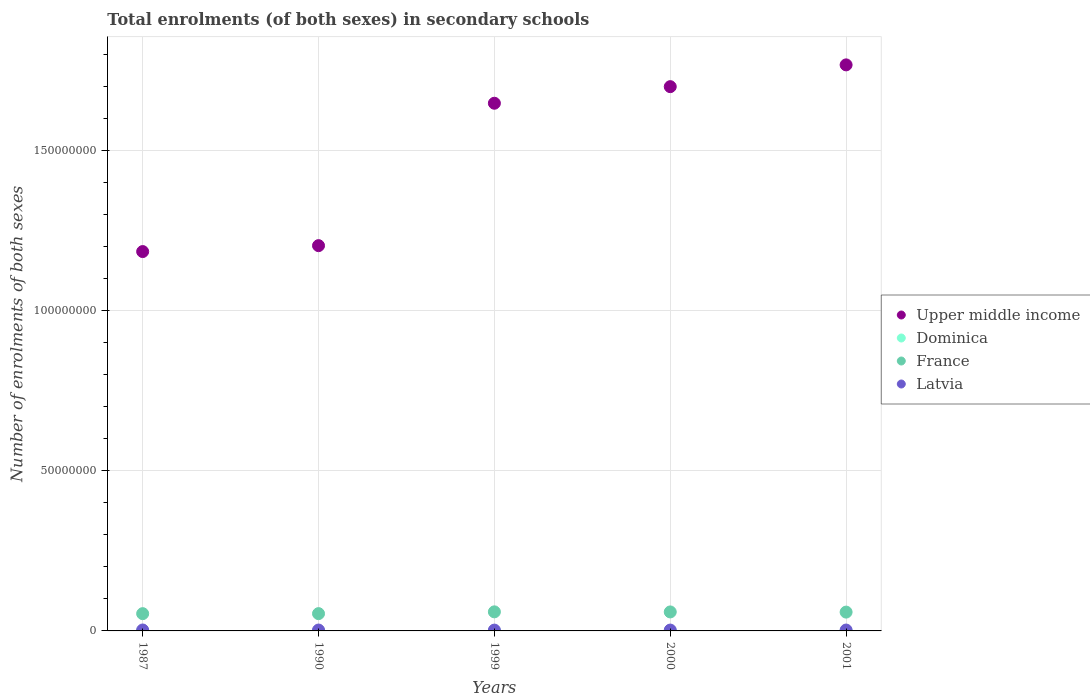What is the number of enrolments in secondary schools in Upper middle income in 1999?
Provide a succinct answer. 1.65e+08. Across all years, what is the maximum number of enrolments in secondary schools in France?
Offer a terse response. 5.96e+06. Across all years, what is the minimum number of enrolments in secondary schools in Latvia?
Provide a short and direct response. 2.55e+05. In which year was the number of enrolments in secondary schools in Dominica maximum?
Your answer should be very brief. 2001. What is the total number of enrolments in secondary schools in Latvia in the graph?
Offer a very short reply. 1.36e+06. What is the difference between the number of enrolments in secondary schools in Latvia in 1999 and that in 2000?
Your response must be concise. -1.11e+04. What is the difference between the number of enrolments in secondary schools in Upper middle income in 1999 and the number of enrolments in secondary schools in Dominica in 1990?
Make the answer very short. 1.65e+08. What is the average number of enrolments in secondary schools in Dominica per year?
Make the answer very short. 6790.6. In the year 2000, what is the difference between the number of enrolments in secondary schools in France and number of enrolments in secondary schools in Latvia?
Offer a terse response. 5.66e+06. In how many years, is the number of enrolments in secondary schools in Upper middle income greater than 170000000?
Provide a short and direct response. 1. What is the ratio of the number of enrolments in secondary schools in Latvia in 2000 to that in 2001?
Your response must be concise. 0.97. Is the difference between the number of enrolments in secondary schools in France in 1987 and 1999 greater than the difference between the number of enrolments in secondary schools in Latvia in 1987 and 1999?
Ensure brevity in your answer.  No. What is the difference between the highest and the second highest number of enrolments in secondary schools in Latvia?
Offer a terse response. 1.36e+04. What is the difference between the highest and the lowest number of enrolments in secondary schools in Latvia?
Your answer should be compact. 3.34e+04. Is it the case that in every year, the sum of the number of enrolments in secondary schools in Dominica and number of enrolments in secondary schools in Upper middle income  is greater than the sum of number of enrolments in secondary schools in France and number of enrolments in secondary schools in Latvia?
Keep it short and to the point. Yes. Is it the case that in every year, the sum of the number of enrolments in secondary schools in France and number of enrolments in secondary schools in Upper middle income  is greater than the number of enrolments in secondary schools in Dominica?
Your answer should be very brief. Yes. Is the number of enrolments in secondary schools in Upper middle income strictly less than the number of enrolments in secondary schools in Dominica over the years?
Offer a terse response. No. How many years are there in the graph?
Your answer should be very brief. 5. Does the graph contain grids?
Offer a very short reply. Yes. Where does the legend appear in the graph?
Offer a terse response. Center right. What is the title of the graph?
Your response must be concise. Total enrolments (of both sexes) in secondary schools. What is the label or title of the X-axis?
Offer a very short reply. Years. What is the label or title of the Y-axis?
Give a very brief answer. Number of enrolments of both sexes. What is the Number of enrolments of both sexes of Upper middle income in 1987?
Keep it short and to the point. 1.18e+08. What is the Number of enrolments of both sexes in Dominica in 1987?
Your response must be concise. 6308. What is the Number of enrolments of both sexes in France in 1987?
Make the answer very short. 5.39e+06. What is the Number of enrolments of both sexes in Latvia in 1987?
Make the answer very short. 2.89e+05. What is the Number of enrolments of both sexes in Upper middle income in 1990?
Provide a succinct answer. 1.20e+08. What is the Number of enrolments of both sexes in Dominica in 1990?
Keep it short and to the point. 5634. What is the Number of enrolments of both sexes of France in 1990?
Your answer should be compact. 5.40e+06. What is the Number of enrolments of both sexes in Latvia in 1990?
Offer a very short reply. 2.75e+05. What is the Number of enrolments of both sexes of Upper middle income in 1999?
Offer a terse response. 1.65e+08. What is the Number of enrolments of both sexes in Dominica in 1999?
Offer a very short reply. 7126. What is the Number of enrolments of both sexes of France in 1999?
Your response must be concise. 5.96e+06. What is the Number of enrolments of both sexes of Latvia in 1999?
Your answer should be very brief. 2.55e+05. What is the Number of enrolments of both sexes in Upper middle income in 2000?
Your answer should be very brief. 1.70e+08. What is the Number of enrolments of both sexes in Dominica in 2000?
Offer a very short reply. 7429. What is the Number of enrolments of both sexes of France in 2000?
Make the answer very short. 5.93e+06. What is the Number of enrolments of both sexes in Latvia in 2000?
Provide a short and direct response. 2.66e+05. What is the Number of enrolments of both sexes in Upper middle income in 2001?
Provide a short and direct response. 1.77e+08. What is the Number of enrolments of both sexes in Dominica in 2001?
Ensure brevity in your answer.  7456. What is the Number of enrolments of both sexes of France in 2001?
Keep it short and to the point. 5.88e+06. What is the Number of enrolments of both sexes in Latvia in 2001?
Give a very brief answer. 2.74e+05. Across all years, what is the maximum Number of enrolments of both sexes in Upper middle income?
Provide a short and direct response. 1.77e+08. Across all years, what is the maximum Number of enrolments of both sexes in Dominica?
Give a very brief answer. 7456. Across all years, what is the maximum Number of enrolments of both sexes in France?
Make the answer very short. 5.96e+06. Across all years, what is the maximum Number of enrolments of both sexes in Latvia?
Offer a terse response. 2.89e+05. Across all years, what is the minimum Number of enrolments of both sexes of Upper middle income?
Provide a succinct answer. 1.18e+08. Across all years, what is the minimum Number of enrolments of both sexes of Dominica?
Provide a succinct answer. 5634. Across all years, what is the minimum Number of enrolments of both sexes in France?
Make the answer very short. 5.39e+06. Across all years, what is the minimum Number of enrolments of both sexes of Latvia?
Your response must be concise. 2.55e+05. What is the total Number of enrolments of both sexes of Upper middle income in the graph?
Provide a succinct answer. 7.50e+08. What is the total Number of enrolments of both sexes of Dominica in the graph?
Ensure brevity in your answer.  3.40e+04. What is the total Number of enrolments of both sexes in France in the graph?
Offer a terse response. 2.85e+07. What is the total Number of enrolments of both sexes of Latvia in the graph?
Your answer should be very brief. 1.36e+06. What is the difference between the Number of enrolments of both sexes in Upper middle income in 1987 and that in 1990?
Your response must be concise. -1.85e+06. What is the difference between the Number of enrolments of both sexes in Dominica in 1987 and that in 1990?
Your response must be concise. 674. What is the difference between the Number of enrolments of both sexes of France in 1987 and that in 1990?
Provide a short and direct response. -8793. What is the difference between the Number of enrolments of both sexes in Latvia in 1987 and that in 1990?
Offer a very short reply. 1.36e+04. What is the difference between the Number of enrolments of both sexes of Upper middle income in 1987 and that in 1999?
Ensure brevity in your answer.  -4.63e+07. What is the difference between the Number of enrolments of both sexes of Dominica in 1987 and that in 1999?
Your answer should be compact. -818. What is the difference between the Number of enrolments of both sexes of France in 1987 and that in 1999?
Provide a succinct answer. -5.66e+05. What is the difference between the Number of enrolments of both sexes of Latvia in 1987 and that in 1999?
Your response must be concise. 3.34e+04. What is the difference between the Number of enrolments of both sexes of Upper middle income in 1987 and that in 2000?
Your response must be concise. -5.15e+07. What is the difference between the Number of enrolments of both sexes of Dominica in 1987 and that in 2000?
Ensure brevity in your answer.  -1121. What is the difference between the Number of enrolments of both sexes in France in 1987 and that in 2000?
Provide a succinct answer. -5.39e+05. What is the difference between the Number of enrolments of both sexes of Latvia in 1987 and that in 2000?
Offer a very short reply. 2.23e+04. What is the difference between the Number of enrolments of both sexes of Upper middle income in 1987 and that in 2001?
Provide a succinct answer. -5.83e+07. What is the difference between the Number of enrolments of both sexes in Dominica in 1987 and that in 2001?
Offer a very short reply. -1148. What is the difference between the Number of enrolments of both sexes in France in 1987 and that in 2001?
Your answer should be compact. -4.86e+05. What is the difference between the Number of enrolments of both sexes in Latvia in 1987 and that in 2001?
Give a very brief answer. 1.46e+04. What is the difference between the Number of enrolments of both sexes in Upper middle income in 1990 and that in 1999?
Your answer should be compact. -4.45e+07. What is the difference between the Number of enrolments of both sexes in Dominica in 1990 and that in 1999?
Offer a very short reply. -1492. What is the difference between the Number of enrolments of both sexes of France in 1990 and that in 1999?
Offer a very short reply. -5.57e+05. What is the difference between the Number of enrolments of both sexes of Latvia in 1990 and that in 1999?
Your response must be concise. 1.97e+04. What is the difference between the Number of enrolments of both sexes of Upper middle income in 1990 and that in 2000?
Ensure brevity in your answer.  -4.96e+07. What is the difference between the Number of enrolments of both sexes of Dominica in 1990 and that in 2000?
Give a very brief answer. -1795. What is the difference between the Number of enrolments of both sexes of France in 1990 and that in 2000?
Provide a succinct answer. -5.30e+05. What is the difference between the Number of enrolments of both sexes in Latvia in 1990 and that in 2000?
Offer a very short reply. 8624. What is the difference between the Number of enrolments of both sexes of Upper middle income in 1990 and that in 2001?
Offer a terse response. -5.64e+07. What is the difference between the Number of enrolments of both sexes of Dominica in 1990 and that in 2001?
Provide a short and direct response. -1822. What is the difference between the Number of enrolments of both sexes of France in 1990 and that in 2001?
Offer a very short reply. -4.77e+05. What is the difference between the Number of enrolments of both sexes of Latvia in 1990 and that in 2001?
Provide a succinct answer. 929. What is the difference between the Number of enrolments of both sexes of Upper middle income in 1999 and that in 2000?
Your answer should be very brief. -5.18e+06. What is the difference between the Number of enrolments of both sexes of Dominica in 1999 and that in 2000?
Your response must be concise. -303. What is the difference between the Number of enrolments of both sexes in France in 1999 and that in 2000?
Make the answer very short. 2.68e+04. What is the difference between the Number of enrolments of both sexes of Latvia in 1999 and that in 2000?
Your answer should be very brief. -1.11e+04. What is the difference between the Number of enrolments of both sexes in Upper middle income in 1999 and that in 2001?
Make the answer very short. -1.20e+07. What is the difference between the Number of enrolments of both sexes in Dominica in 1999 and that in 2001?
Give a very brief answer. -330. What is the difference between the Number of enrolments of both sexes in France in 1999 and that in 2001?
Keep it short and to the point. 7.94e+04. What is the difference between the Number of enrolments of both sexes of Latvia in 1999 and that in 2001?
Your response must be concise. -1.88e+04. What is the difference between the Number of enrolments of both sexes in Upper middle income in 2000 and that in 2001?
Your answer should be compact. -6.80e+06. What is the difference between the Number of enrolments of both sexes in France in 2000 and that in 2001?
Offer a very short reply. 5.27e+04. What is the difference between the Number of enrolments of both sexes of Latvia in 2000 and that in 2001?
Keep it short and to the point. -7695. What is the difference between the Number of enrolments of both sexes of Upper middle income in 1987 and the Number of enrolments of both sexes of Dominica in 1990?
Offer a terse response. 1.18e+08. What is the difference between the Number of enrolments of both sexes of Upper middle income in 1987 and the Number of enrolments of both sexes of France in 1990?
Make the answer very short. 1.13e+08. What is the difference between the Number of enrolments of both sexes in Upper middle income in 1987 and the Number of enrolments of both sexes in Latvia in 1990?
Give a very brief answer. 1.18e+08. What is the difference between the Number of enrolments of both sexes in Dominica in 1987 and the Number of enrolments of both sexes in France in 1990?
Offer a terse response. -5.39e+06. What is the difference between the Number of enrolments of both sexes in Dominica in 1987 and the Number of enrolments of both sexes in Latvia in 1990?
Offer a terse response. -2.69e+05. What is the difference between the Number of enrolments of both sexes of France in 1987 and the Number of enrolments of both sexes of Latvia in 1990?
Your response must be concise. 5.11e+06. What is the difference between the Number of enrolments of both sexes of Upper middle income in 1987 and the Number of enrolments of both sexes of Dominica in 1999?
Your response must be concise. 1.18e+08. What is the difference between the Number of enrolments of both sexes of Upper middle income in 1987 and the Number of enrolments of both sexes of France in 1999?
Your response must be concise. 1.12e+08. What is the difference between the Number of enrolments of both sexes in Upper middle income in 1987 and the Number of enrolments of both sexes in Latvia in 1999?
Make the answer very short. 1.18e+08. What is the difference between the Number of enrolments of both sexes of Dominica in 1987 and the Number of enrolments of both sexes of France in 1999?
Offer a very short reply. -5.95e+06. What is the difference between the Number of enrolments of both sexes of Dominica in 1987 and the Number of enrolments of both sexes of Latvia in 1999?
Your answer should be very brief. -2.49e+05. What is the difference between the Number of enrolments of both sexes of France in 1987 and the Number of enrolments of both sexes of Latvia in 1999?
Offer a terse response. 5.13e+06. What is the difference between the Number of enrolments of both sexes in Upper middle income in 1987 and the Number of enrolments of both sexes in Dominica in 2000?
Your response must be concise. 1.18e+08. What is the difference between the Number of enrolments of both sexes of Upper middle income in 1987 and the Number of enrolments of both sexes of France in 2000?
Provide a short and direct response. 1.13e+08. What is the difference between the Number of enrolments of both sexes of Upper middle income in 1987 and the Number of enrolments of both sexes of Latvia in 2000?
Ensure brevity in your answer.  1.18e+08. What is the difference between the Number of enrolments of both sexes of Dominica in 1987 and the Number of enrolments of both sexes of France in 2000?
Your answer should be compact. -5.92e+06. What is the difference between the Number of enrolments of both sexes of Dominica in 1987 and the Number of enrolments of both sexes of Latvia in 2000?
Offer a terse response. -2.60e+05. What is the difference between the Number of enrolments of both sexes in France in 1987 and the Number of enrolments of both sexes in Latvia in 2000?
Provide a short and direct response. 5.12e+06. What is the difference between the Number of enrolments of both sexes of Upper middle income in 1987 and the Number of enrolments of both sexes of Dominica in 2001?
Provide a short and direct response. 1.18e+08. What is the difference between the Number of enrolments of both sexes of Upper middle income in 1987 and the Number of enrolments of both sexes of France in 2001?
Your answer should be compact. 1.13e+08. What is the difference between the Number of enrolments of both sexes of Upper middle income in 1987 and the Number of enrolments of both sexes of Latvia in 2001?
Your response must be concise. 1.18e+08. What is the difference between the Number of enrolments of both sexes in Dominica in 1987 and the Number of enrolments of both sexes in France in 2001?
Offer a very short reply. -5.87e+06. What is the difference between the Number of enrolments of both sexes of Dominica in 1987 and the Number of enrolments of both sexes of Latvia in 2001?
Your response must be concise. -2.68e+05. What is the difference between the Number of enrolments of both sexes in France in 1987 and the Number of enrolments of both sexes in Latvia in 2001?
Make the answer very short. 5.12e+06. What is the difference between the Number of enrolments of both sexes in Upper middle income in 1990 and the Number of enrolments of both sexes in Dominica in 1999?
Give a very brief answer. 1.20e+08. What is the difference between the Number of enrolments of both sexes in Upper middle income in 1990 and the Number of enrolments of both sexes in France in 1999?
Offer a terse response. 1.14e+08. What is the difference between the Number of enrolments of both sexes of Upper middle income in 1990 and the Number of enrolments of both sexes of Latvia in 1999?
Offer a terse response. 1.20e+08. What is the difference between the Number of enrolments of both sexes in Dominica in 1990 and the Number of enrolments of both sexes in France in 1999?
Make the answer very short. -5.95e+06. What is the difference between the Number of enrolments of both sexes in Dominica in 1990 and the Number of enrolments of both sexes in Latvia in 1999?
Provide a succinct answer. -2.50e+05. What is the difference between the Number of enrolments of both sexes in France in 1990 and the Number of enrolments of both sexes in Latvia in 1999?
Provide a short and direct response. 5.14e+06. What is the difference between the Number of enrolments of both sexes in Upper middle income in 1990 and the Number of enrolments of both sexes in Dominica in 2000?
Your response must be concise. 1.20e+08. What is the difference between the Number of enrolments of both sexes in Upper middle income in 1990 and the Number of enrolments of both sexes in France in 2000?
Keep it short and to the point. 1.14e+08. What is the difference between the Number of enrolments of both sexes of Upper middle income in 1990 and the Number of enrolments of both sexes of Latvia in 2000?
Make the answer very short. 1.20e+08. What is the difference between the Number of enrolments of both sexes in Dominica in 1990 and the Number of enrolments of both sexes in France in 2000?
Keep it short and to the point. -5.92e+06. What is the difference between the Number of enrolments of both sexes in Dominica in 1990 and the Number of enrolments of both sexes in Latvia in 2000?
Provide a short and direct response. -2.61e+05. What is the difference between the Number of enrolments of both sexes in France in 1990 and the Number of enrolments of both sexes in Latvia in 2000?
Give a very brief answer. 5.13e+06. What is the difference between the Number of enrolments of both sexes of Upper middle income in 1990 and the Number of enrolments of both sexes of Dominica in 2001?
Keep it short and to the point. 1.20e+08. What is the difference between the Number of enrolments of both sexes in Upper middle income in 1990 and the Number of enrolments of both sexes in France in 2001?
Offer a terse response. 1.14e+08. What is the difference between the Number of enrolments of both sexes in Upper middle income in 1990 and the Number of enrolments of both sexes in Latvia in 2001?
Provide a short and direct response. 1.20e+08. What is the difference between the Number of enrolments of both sexes in Dominica in 1990 and the Number of enrolments of both sexes in France in 2001?
Provide a short and direct response. -5.87e+06. What is the difference between the Number of enrolments of both sexes of Dominica in 1990 and the Number of enrolments of both sexes of Latvia in 2001?
Ensure brevity in your answer.  -2.69e+05. What is the difference between the Number of enrolments of both sexes of France in 1990 and the Number of enrolments of both sexes of Latvia in 2001?
Offer a terse response. 5.12e+06. What is the difference between the Number of enrolments of both sexes of Upper middle income in 1999 and the Number of enrolments of both sexes of Dominica in 2000?
Your response must be concise. 1.65e+08. What is the difference between the Number of enrolments of both sexes of Upper middle income in 1999 and the Number of enrolments of both sexes of France in 2000?
Ensure brevity in your answer.  1.59e+08. What is the difference between the Number of enrolments of both sexes of Upper middle income in 1999 and the Number of enrolments of both sexes of Latvia in 2000?
Your answer should be compact. 1.64e+08. What is the difference between the Number of enrolments of both sexes in Dominica in 1999 and the Number of enrolments of both sexes in France in 2000?
Give a very brief answer. -5.92e+06. What is the difference between the Number of enrolments of both sexes of Dominica in 1999 and the Number of enrolments of both sexes of Latvia in 2000?
Offer a terse response. -2.59e+05. What is the difference between the Number of enrolments of both sexes in France in 1999 and the Number of enrolments of both sexes in Latvia in 2000?
Provide a succinct answer. 5.69e+06. What is the difference between the Number of enrolments of both sexes of Upper middle income in 1999 and the Number of enrolments of both sexes of Dominica in 2001?
Offer a very short reply. 1.65e+08. What is the difference between the Number of enrolments of both sexes of Upper middle income in 1999 and the Number of enrolments of both sexes of France in 2001?
Give a very brief answer. 1.59e+08. What is the difference between the Number of enrolments of both sexes of Upper middle income in 1999 and the Number of enrolments of both sexes of Latvia in 2001?
Give a very brief answer. 1.64e+08. What is the difference between the Number of enrolments of both sexes in Dominica in 1999 and the Number of enrolments of both sexes in France in 2001?
Offer a terse response. -5.87e+06. What is the difference between the Number of enrolments of both sexes in Dominica in 1999 and the Number of enrolments of both sexes in Latvia in 2001?
Your answer should be very brief. -2.67e+05. What is the difference between the Number of enrolments of both sexes in France in 1999 and the Number of enrolments of both sexes in Latvia in 2001?
Keep it short and to the point. 5.68e+06. What is the difference between the Number of enrolments of both sexes of Upper middle income in 2000 and the Number of enrolments of both sexes of Dominica in 2001?
Provide a succinct answer. 1.70e+08. What is the difference between the Number of enrolments of both sexes of Upper middle income in 2000 and the Number of enrolments of both sexes of France in 2001?
Make the answer very short. 1.64e+08. What is the difference between the Number of enrolments of both sexes in Upper middle income in 2000 and the Number of enrolments of both sexes in Latvia in 2001?
Ensure brevity in your answer.  1.70e+08. What is the difference between the Number of enrolments of both sexes in Dominica in 2000 and the Number of enrolments of both sexes in France in 2001?
Offer a terse response. -5.87e+06. What is the difference between the Number of enrolments of both sexes of Dominica in 2000 and the Number of enrolments of both sexes of Latvia in 2001?
Your answer should be compact. -2.67e+05. What is the difference between the Number of enrolments of both sexes of France in 2000 and the Number of enrolments of both sexes of Latvia in 2001?
Make the answer very short. 5.65e+06. What is the average Number of enrolments of both sexes in Upper middle income per year?
Your response must be concise. 1.50e+08. What is the average Number of enrolments of both sexes in Dominica per year?
Your answer should be compact. 6790.6. What is the average Number of enrolments of both sexes of France per year?
Make the answer very short. 5.71e+06. What is the average Number of enrolments of both sexes in Latvia per year?
Your answer should be very brief. 2.72e+05. In the year 1987, what is the difference between the Number of enrolments of both sexes in Upper middle income and Number of enrolments of both sexes in Dominica?
Your answer should be very brief. 1.18e+08. In the year 1987, what is the difference between the Number of enrolments of both sexes in Upper middle income and Number of enrolments of both sexes in France?
Ensure brevity in your answer.  1.13e+08. In the year 1987, what is the difference between the Number of enrolments of both sexes of Upper middle income and Number of enrolments of both sexes of Latvia?
Provide a short and direct response. 1.18e+08. In the year 1987, what is the difference between the Number of enrolments of both sexes in Dominica and Number of enrolments of both sexes in France?
Your answer should be very brief. -5.38e+06. In the year 1987, what is the difference between the Number of enrolments of both sexes in Dominica and Number of enrolments of both sexes in Latvia?
Your response must be concise. -2.82e+05. In the year 1987, what is the difference between the Number of enrolments of both sexes of France and Number of enrolments of both sexes of Latvia?
Your response must be concise. 5.10e+06. In the year 1990, what is the difference between the Number of enrolments of both sexes in Upper middle income and Number of enrolments of both sexes in Dominica?
Your answer should be very brief. 1.20e+08. In the year 1990, what is the difference between the Number of enrolments of both sexes in Upper middle income and Number of enrolments of both sexes in France?
Your response must be concise. 1.15e+08. In the year 1990, what is the difference between the Number of enrolments of both sexes in Upper middle income and Number of enrolments of both sexes in Latvia?
Ensure brevity in your answer.  1.20e+08. In the year 1990, what is the difference between the Number of enrolments of both sexes of Dominica and Number of enrolments of both sexes of France?
Provide a short and direct response. -5.39e+06. In the year 1990, what is the difference between the Number of enrolments of both sexes of Dominica and Number of enrolments of both sexes of Latvia?
Offer a terse response. -2.69e+05. In the year 1990, what is the difference between the Number of enrolments of both sexes in France and Number of enrolments of both sexes in Latvia?
Offer a terse response. 5.12e+06. In the year 1999, what is the difference between the Number of enrolments of both sexes in Upper middle income and Number of enrolments of both sexes in Dominica?
Give a very brief answer. 1.65e+08. In the year 1999, what is the difference between the Number of enrolments of both sexes of Upper middle income and Number of enrolments of both sexes of France?
Provide a succinct answer. 1.59e+08. In the year 1999, what is the difference between the Number of enrolments of both sexes of Upper middle income and Number of enrolments of both sexes of Latvia?
Your answer should be very brief. 1.64e+08. In the year 1999, what is the difference between the Number of enrolments of both sexes of Dominica and Number of enrolments of both sexes of France?
Give a very brief answer. -5.95e+06. In the year 1999, what is the difference between the Number of enrolments of both sexes of Dominica and Number of enrolments of both sexes of Latvia?
Provide a succinct answer. -2.48e+05. In the year 1999, what is the difference between the Number of enrolments of both sexes in France and Number of enrolments of both sexes in Latvia?
Keep it short and to the point. 5.70e+06. In the year 2000, what is the difference between the Number of enrolments of both sexes of Upper middle income and Number of enrolments of both sexes of Dominica?
Keep it short and to the point. 1.70e+08. In the year 2000, what is the difference between the Number of enrolments of both sexes in Upper middle income and Number of enrolments of both sexes in France?
Provide a succinct answer. 1.64e+08. In the year 2000, what is the difference between the Number of enrolments of both sexes of Upper middle income and Number of enrolments of both sexes of Latvia?
Your response must be concise. 1.70e+08. In the year 2000, what is the difference between the Number of enrolments of both sexes of Dominica and Number of enrolments of both sexes of France?
Make the answer very short. -5.92e+06. In the year 2000, what is the difference between the Number of enrolments of both sexes of Dominica and Number of enrolments of both sexes of Latvia?
Offer a terse response. -2.59e+05. In the year 2000, what is the difference between the Number of enrolments of both sexes of France and Number of enrolments of both sexes of Latvia?
Give a very brief answer. 5.66e+06. In the year 2001, what is the difference between the Number of enrolments of both sexes of Upper middle income and Number of enrolments of both sexes of Dominica?
Give a very brief answer. 1.77e+08. In the year 2001, what is the difference between the Number of enrolments of both sexes of Upper middle income and Number of enrolments of both sexes of France?
Offer a terse response. 1.71e+08. In the year 2001, what is the difference between the Number of enrolments of both sexes in Upper middle income and Number of enrolments of both sexes in Latvia?
Ensure brevity in your answer.  1.76e+08. In the year 2001, what is the difference between the Number of enrolments of both sexes in Dominica and Number of enrolments of both sexes in France?
Give a very brief answer. -5.87e+06. In the year 2001, what is the difference between the Number of enrolments of both sexes of Dominica and Number of enrolments of both sexes of Latvia?
Keep it short and to the point. -2.67e+05. In the year 2001, what is the difference between the Number of enrolments of both sexes in France and Number of enrolments of both sexes in Latvia?
Ensure brevity in your answer.  5.60e+06. What is the ratio of the Number of enrolments of both sexes in Upper middle income in 1987 to that in 1990?
Your response must be concise. 0.98. What is the ratio of the Number of enrolments of both sexes of Dominica in 1987 to that in 1990?
Your response must be concise. 1.12. What is the ratio of the Number of enrolments of both sexes of Latvia in 1987 to that in 1990?
Provide a succinct answer. 1.05. What is the ratio of the Number of enrolments of both sexes of Upper middle income in 1987 to that in 1999?
Keep it short and to the point. 0.72. What is the ratio of the Number of enrolments of both sexes of Dominica in 1987 to that in 1999?
Your answer should be compact. 0.89. What is the ratio of the Number of enrolments of both sexes of France in 1987 to that in 1999?
Your response must be concise. 0.91. What is the ratio of the Number of enrolments of both sexes in Latvia in 1987 to that in 1999?
Provide a succinct answer. 1.13. What is the ratio of the Number of enrolments of both sexes in Upper middle income in 1987 to that in 2000?
Make the answer very short. 0.7. What is the ratio of the Number of enrolments of both sexes of Dominica in 1987 to that in 2000?
Your response must be concise. 0.85. What is the ratio of the Number of enrolments of both sexes of Latvia in 1987 to that in 2000?
Keep it short and to the point. 1.08. What is the ratio of the Number of enrolments of both sexes in Upper middle income in 1987 to that in 2001?
Keep it short and to the point. 0.67. What is the ratio of the Number of enrolments of both sexes of Dominica in 1987 to that in 2001?
Give a very brief answer. 0.85. What is the ratio of the Number of enrolments of both sexes of France in 1987 to that in 2001?
Provide a short and direct response. 0.92. What is the ratio of the Number of enrolments of both sexes in Latvia in 1987 to that in 2001?
Keep it short and to the point. 1.05. What is the ratio of the Number of enrolments of both sexes of Upper middle income in 1990 to that in 1999?
Your response must be concise. 0.73. What is the ratio of the Number of enrolments of both sexes of Dominica in 1990 to that in 1999?
Offer a terse response. 0.79. What is the ratio of the Number of enrolments of both sexes of France in 1990 to that in 1999?
Provide a succinct answer. 0.91. What is the ratio of the Number of enrolments of both sexes of Latvia in 1990 to that in 1999?
Your answer should be compact. 1.08. What is the ratio of the Number of enrolments of both sexes of Upper middle income in 1990 to that in 2000?
Provide a succinct answer. 0.71. What is the ratio of the Number of enrolments of both sexes of Dominica in 1990 to that in 2000?
Provide a short and direct response. 0.76. What is the ratio of the Number of enrolments of both sexes of France in 1990 to that in 2000?
Provide a short and direct response. 0.91. What is the ratio of the Number of enrolments of both sexes of Latvia in 1990 to that in 2000?
Offer a very short reply. 1.03. What is the ratio of the Number of enrolments of both sexes in Upper middle income in 1990 to that in 2001?
Ensure brevity in your answer.  0.68. What is the ratio of the Number of enrolments of both sexes of Dominica in 1990 to that in 2001?
Offer a terse response. 0.76. What is the ratio of the Number of enrolments of both sexes of France in 1990 to that in 2001?
Provide a short and direct response. 0.92. What is the ratio of the Number of enrolments of both sexes of Upper middle income in 1999 to that in 2000?
Keep it short and to the point. 0.97. What is the ratio of the Number of enrolments of both sexes in Dominica in 1999 to that in 2000?
Give a very brief answer. 0.96. What is the ratio of the Number of enrolments of both sexes in Upper middle income in 1999 to that in 2001?
Make the answer very short. 0.93. What is the ratio of the Number of enrolments of both sexes of Dominica in 1999 to that in 2001?
Provide a succinct answer. 0.96. What is the ratio of the Number of enrolments of both sexes of France in 1999 to that in 2001?
Give a very brief answer. 1.01. What is the ratio of the Number of enrolments of both sexes in Latvia in 1999 to that in 2001?
Give a very brief answer. 0.93. What is the ratio of the Number of enrolments of both sexes in Upper middle income in 2000 to that in 2001?
Keep it short and to the point. 0.96. What is the ratio of the Number of enrolments of both sexes in Dominica in 2000 to that in 2001?
Offer a very short reply. 1. What is the ratio of the Number of enrolments of both sexes of France in 2000 to that in 2001?
Keep it short and to the point. 1.01. What is the ratio of the Number of enrolments of both sexes of Latvia in 2000 to that in 2001?
Your answer should be very brief. 0.97. What is the difference between the highest and the second highest Number of enrolments of both sexes in Upper middle income?
Give a very brief answer. 6.80e+06. What is the difference between the highest and the second highest Number of enrolments of both sexes of Dominica?
Provide a short and direct response. 27. What is the difference between the highest and the second highest Number of enrolments of both sexes of France?
Make the answer very short. 2.68e+04. What is the difference between the highest and the second highest Number of enrolments of both sexes of Latvia?
Ensure brevity in your answer.  1.36e+04. What is the difference between the highest and the lowest Number of enrolments of both sexes of Upper middle income?
Your answer should be very brief. 5.83e+07. What is the difference between the highest and the lowest Number of enrolments of both sexes in Dominica?
Make the answer very short. 1822. What is the difference between the highest and the lowest Number of enrolments of both sexes in France?
Make the answer very short. 5.66e+05. What is the difference between the highest and the lowest Number of enrolments of both sexes in Latvia?
Offer a terse response. 3.34e+04. 